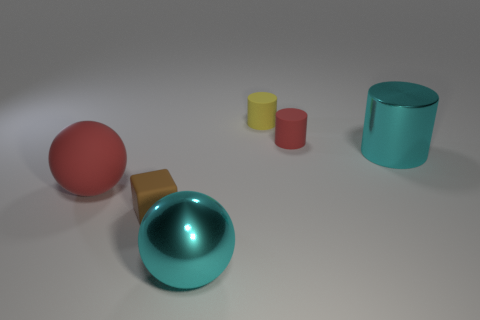Subtract all tiny yellow cylinders. How many cylinders are left? 2 Add 2 cyan metal cubes. How many objects exist? 8 Subtract 1 blocks. How many blocks are left? 0 Subtract all red cylinders. How many cylinders are left? 2 Subtract all blocks. How many objects are left? 5 Subtract all green cylinders. How many red balls are left? 1 Subtract all rubber cubes. Subtract all big metal cylinders. How many objects are left? 4 Add 4 large shiny spheres. How many large shiny spheres are left? 5 Add 1 tiny blocks. How many tiny blocks exist? 2 Subtract 1 cyan cylinders. How many objects are left? 5 